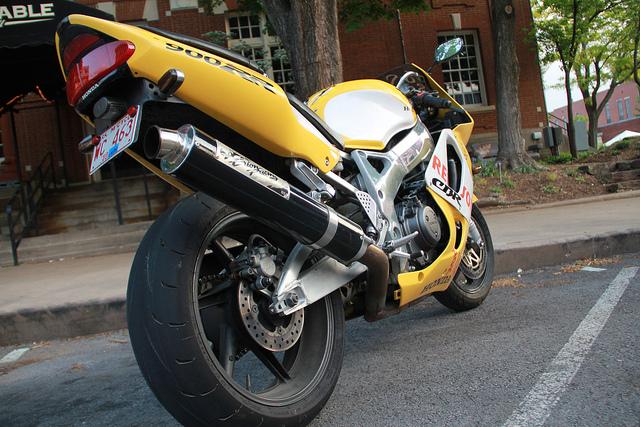What color is the motorcycle?
Concise answer only. Yellow. Is the motorcycle moving?
Keep it brief. No. Does the motorcycle have a license plate?
Keep it brief. Yes. 